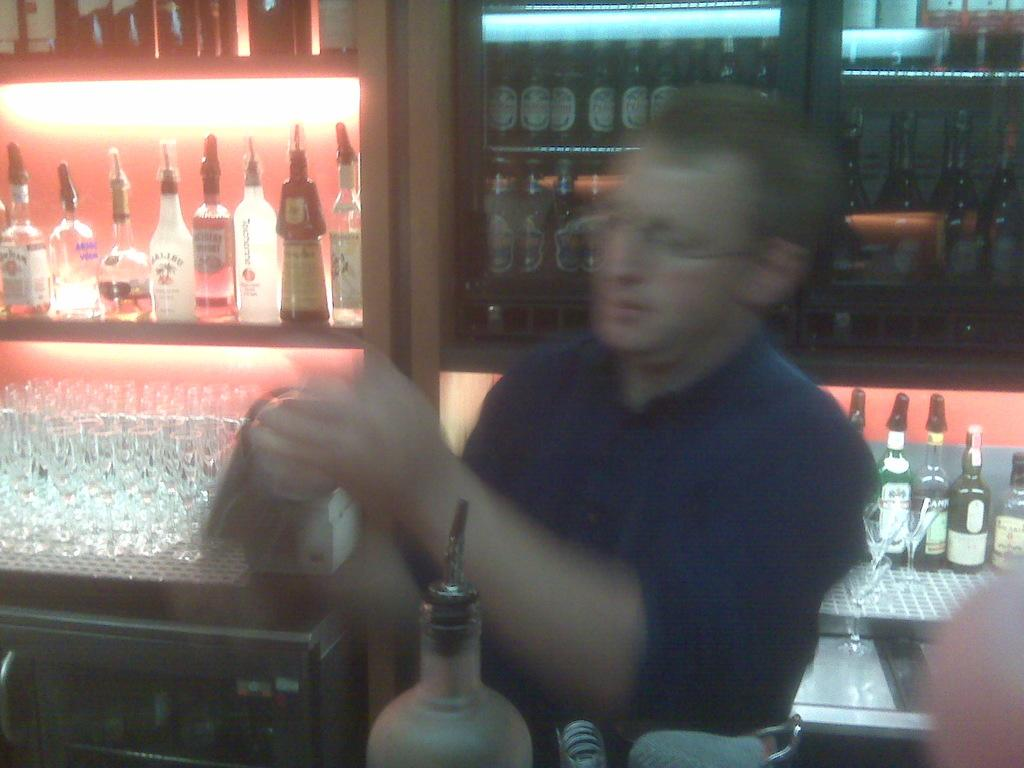What is the main subject of the image? There is a man standing in the image. What objects can be seen near the man? There are glasses in the image. Where are the bottles located in the image? There are bottles on a shelf and in a cupboard in the image. What type of goat can be seen making a statement in the image? There is no goat present in the image, and therefore no such activity can be observed. 